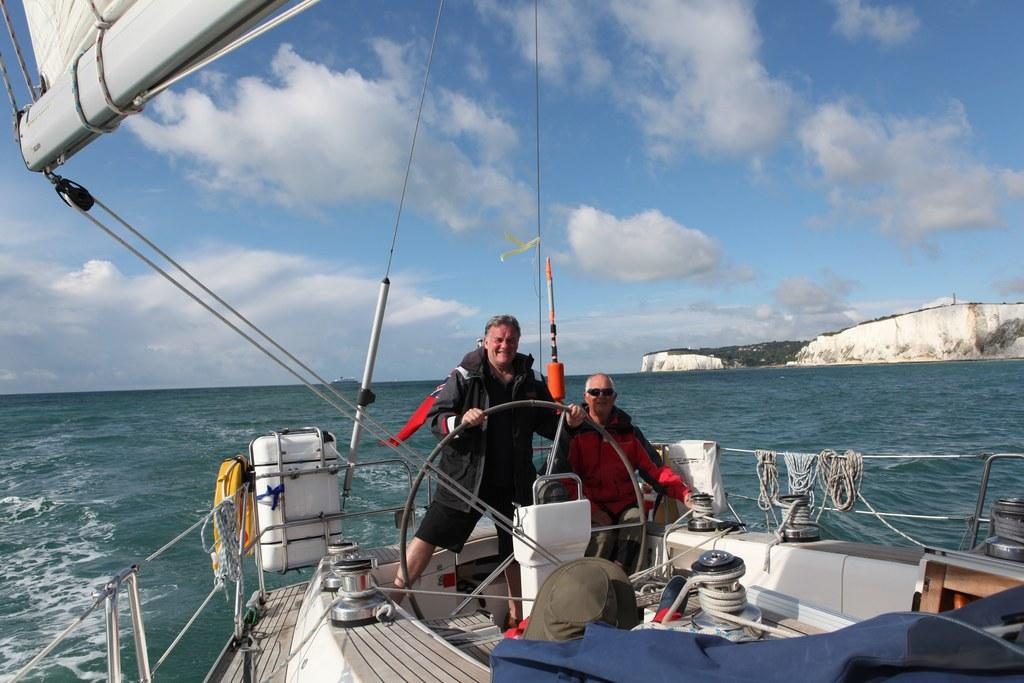What is the condition of the sky in the image? The sky is cloudy in the image. What are the two people doing in the image? The two people are on a boat and holding wheels. What is visible in the background of the image? There is water in the background of the image. What other objects can be seen in the image? Ropes and other things are visible in the image. What type of needle is being used by the people on the boat in the image? There is no needle present in the image; the people are holding wheels. What kind of toy can be seen floating in the water in the image? There is no toy visible in the water in the image; only the boat, people, and other objects are present. 